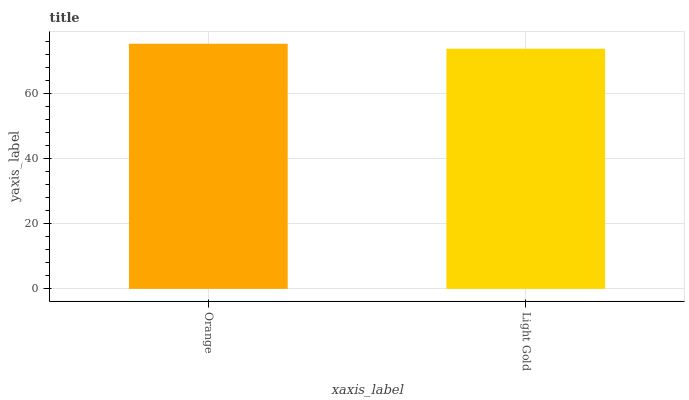Is Light Gold the maximum?
Answer yes or no. No. Is Orange greater than Light Gold?
Answer yes or no. Yes. Is Light Gold less than Orange?
Answer yes or no. Yes. Is Light Gold greater than Orange?
Answer yes or no. No. Is Orange less than Light Gold?
Answer yes or no. No. Is Orange the high median?
Answer yes or no. Yes. Is Light Gold the low median?
Answer yes or no. Yes. Is Light Gold the high median?
Answer yes or no. No. Is Orange the low median?
Answer yes or no. No. 